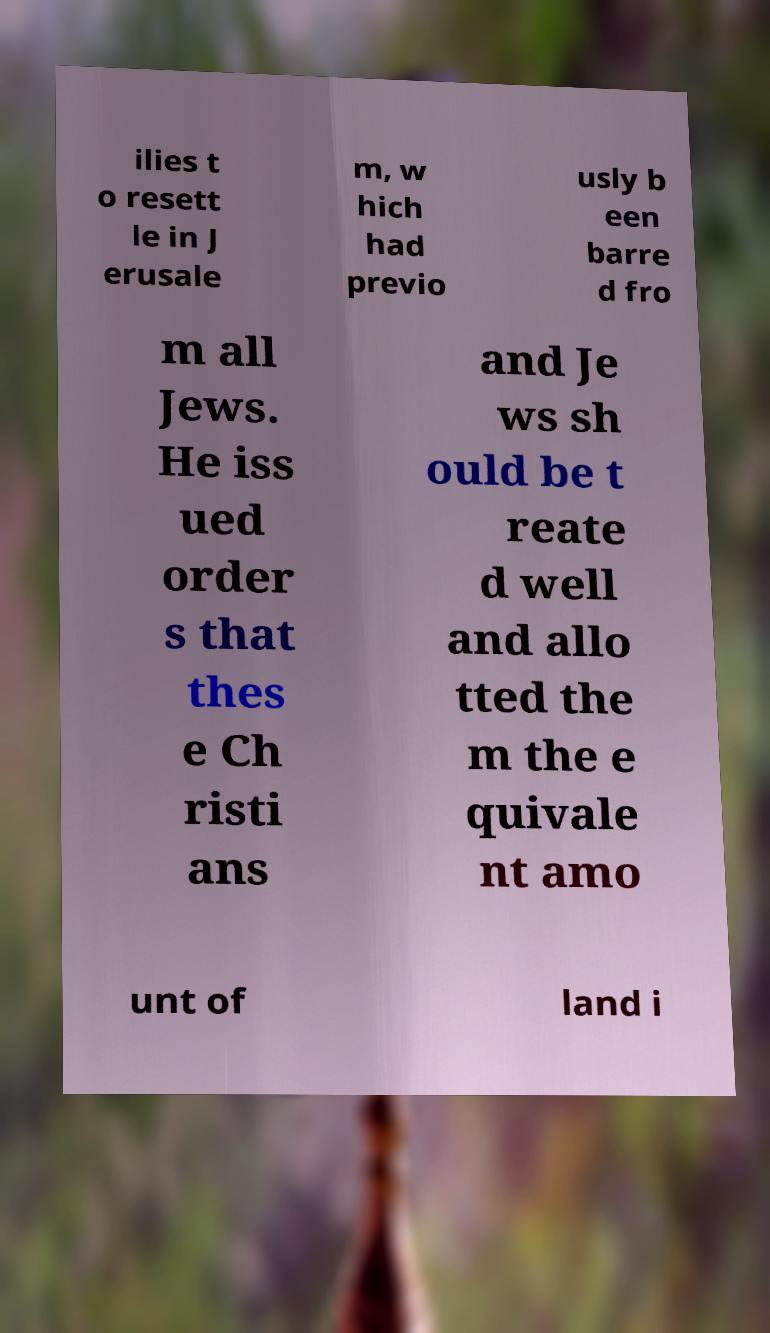Can you accurately transcribe the text from the provided image for me? ilies t o resett le in J erusale m, w hich had previo usly b een barre d fro m all Jews. He iss ued order s that thes e Ch risti ans and Je ws sh ould be t reate d well and allo tted the m the e quivale nt amo unt of land i 